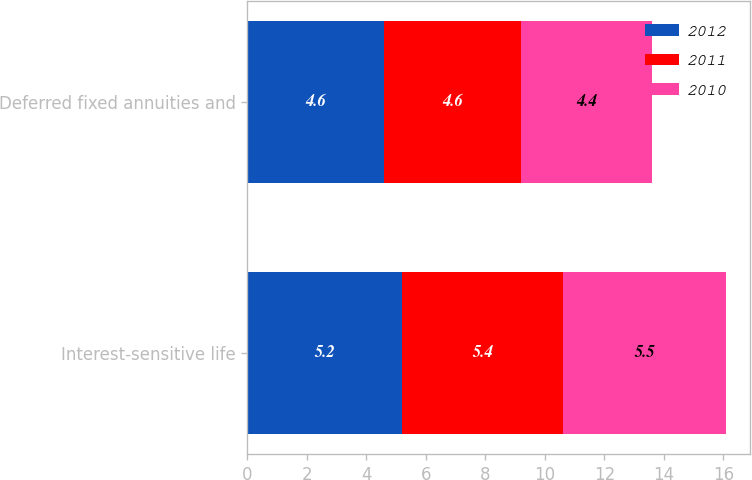<chart> <loc_0><loc_0><loc_500><loc_500><stacked_bar_chart><ecel><fcel>Interest-sensitive life<fcel>Deferred fixed annuities and<nl><fcel>2012<fcel>5.2<fcel>4.6<nl><fcel>2011<fcel>5.4<fcel>4.6<nl><fcel>2010<fcel>5.5<fcel>4.4<nl></chart> 